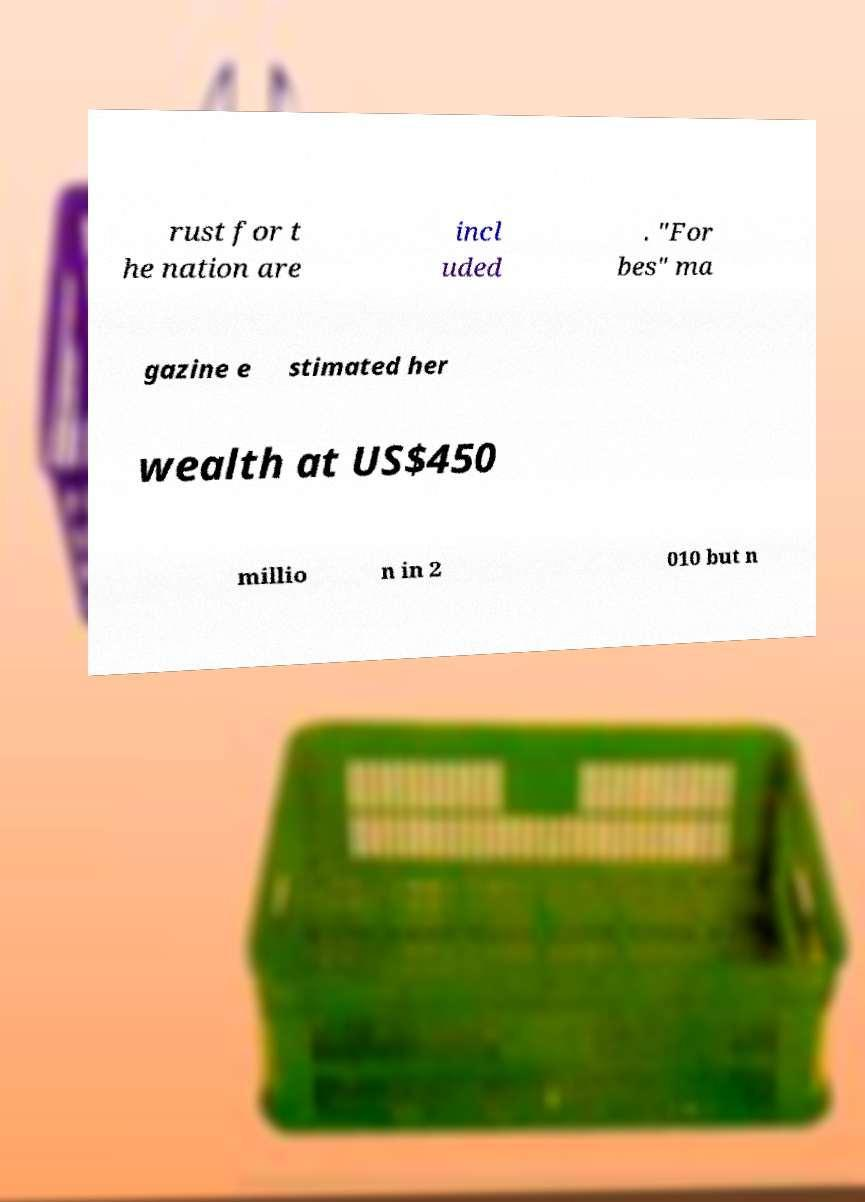What messages or text are displayed in this image? I need them in a readable, typed format. rust for t he nation are incl uded . "For bes" ma gazine e stimated her wealth at US$450 millio n in 2 010 but n 